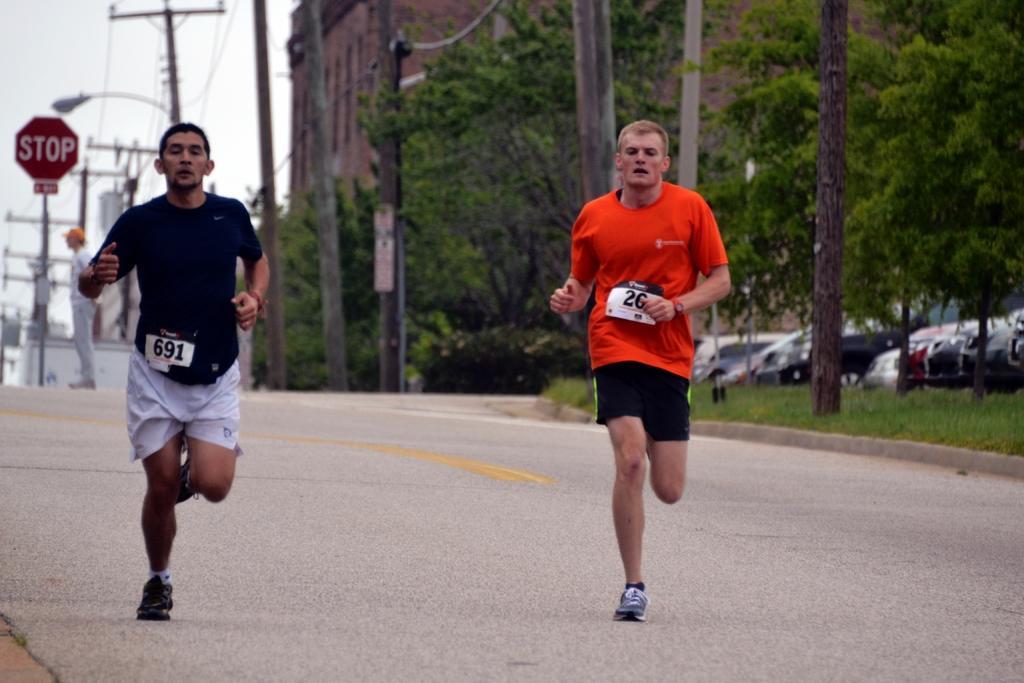Could you give a brief overview of what you see in this image? In this image there are two people running on the road. Left side there is a person standing. There is a board attached to the pole. There are poles connected with the wires. Left side there is a street light. Right side there is a tree trunk on the grassland. Right side there are vehicles. Background there are trees and buildings. Left top there is sky. 